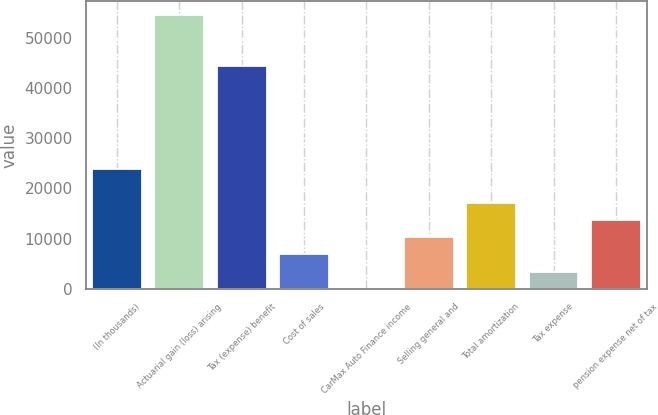Convert chart. <chart><loc_0><loc_0><loc_500><loc_500><bar_chart><fcel>(In thousands)<fcel>Actuarial gain (loss) arising<fcel>Tax (expense) benefit<fcel>Cost of sales<fcel>CarMax Auto Finance income<fcel>Selling general and<fcel>Total amortization<fcel>Tax expense<fcel>pension expense net of tax<nl><fcel>23897.5<fcel>54583<fcel>44354.5<fcel>6850<fcel>31<fcel>10259.5<fcel>17078.5<fcel>3440.5<fcel>13669<nl></chart> 